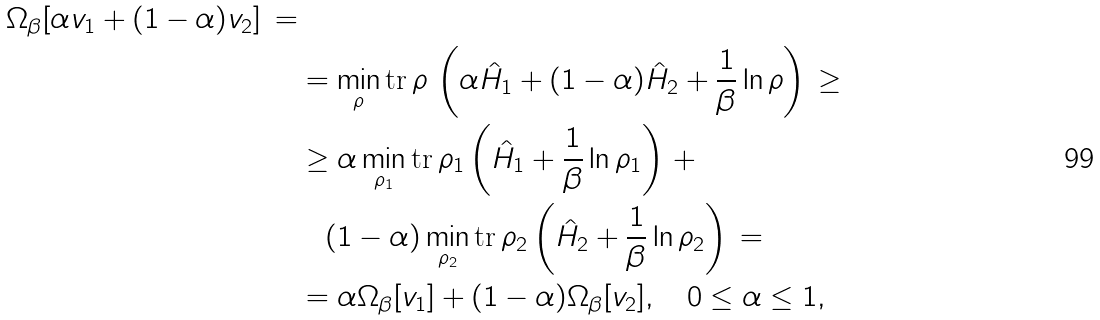Convert formula to latex. <formula><loc_0><loc_0><loc_500><loc_500>{ \Omega _ { \beta } [ \alpha v _ { 1 } + ( 1 - \alpha ) v _ { 2 } ] \, = } \\ & = \min _ { \rho } \text {tr} \, \rho \, \left ( \alpha \hat { H } _ { 1 } + ( 1 - \alpha ) \hat { H } _ { 2 } + \frac { 1 } { \beta } \ln \rho \right ) \, \geq \\ & \geq \alpha \min _ { \rho _ { 1 } } \text {tr} \, \rho _ { 1 } \left ( \hat { H } _ { 1 } + \frac { 1 } { \beta } \ln \rho _ { 1 } \right ) \, + \\ & \quad ( 1 - \alpha ) \min _ { \rho _ { 2 } } \text {tr} \, \rho _ { 2 } \left ( \hat { H } _ { 2 } + \frac { 1 } { \beta } \ln \rho _ { 2 } \right ) \, = \\ & = \alpha \Omega _ { \beta } [ v _ { 1 } ] + ( 1 - \alpha ) \Omega _ { \beta } [ v _ { 2 } ] , \quad 0 \leq \alpha \leq 1 ,</formula> 